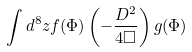<formula> <loc_0><loc_0><loc_500><loc_500>\int d ^ { 8 } z f ( \Phi ) \left ( - \frac { D ^ { 2 } } { 4 \Box } \right ) g ( \Phi )</formula> 